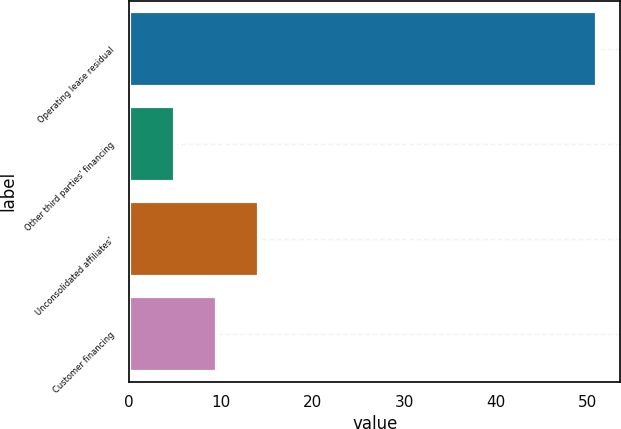Convert chart. <chart><loc_0><loc_0><loc_500><loc_500><bar_chart><fcel>Operating lease residual<fcel>Other third parties' financing<fcel>Unconsolidated affiliates'<fcel>Customer financing<nl><fcel>51<fcel>5<fcel>14.2<fcel>9.6<nl></chart> 